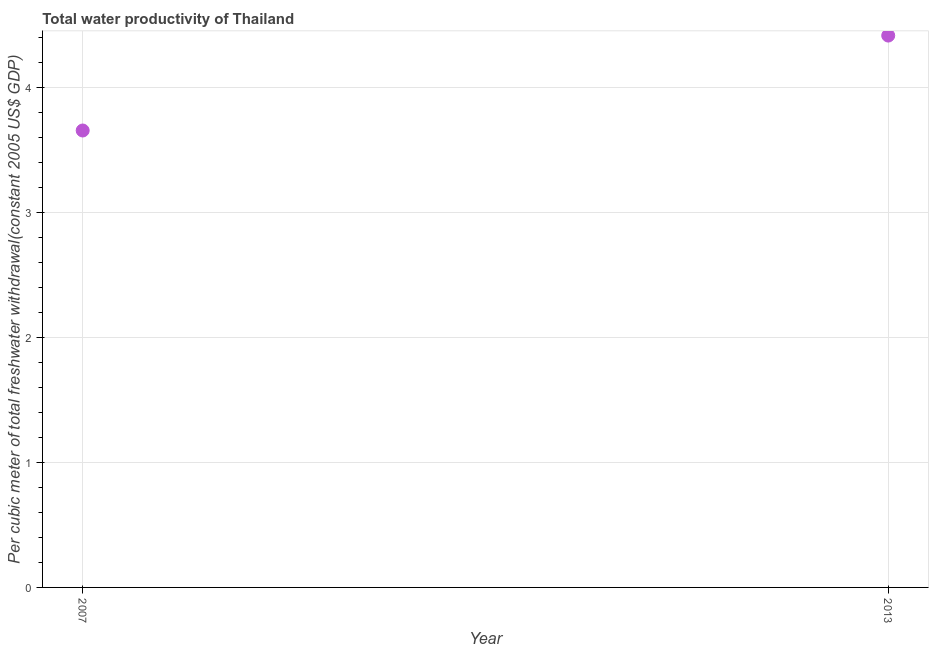What is the total water productivity in 2013?
Keep it short and to the point. 4.42. Across all years, what is the maximum total water productivity?
Provide a short and direct response. 4.42. Across all years, what is the minimum total water productivity?
Offer a terse response. 3.66. In which year was the total water productivity maximum?
Your answer should be compact. 2013. In which year was the total water productivity minimum?
Your answer should be compact. 2007. What is the sum of the total water productivity?
Provide a succinct answer. 8.07. What is the difference between the total water productivity in 2007 and 2013?
Provide a short and direct response. -0.76. What is the average total water productivity per year?
Provide a short and direct response. 4.04. What is the median total water productivity?
Your response must be concise. 4.04. In how many years, is the total water productivity greater than 3.4 US$?
Offer a terse response. 2. Do a majority of the years between 2013 and 2007 (inclusive) have total water productivity greater than 0.2 US$?
Your response must be concise. No. What is the ratio of the total water productivity in 2007 to that in 2013?
Your answer should be very brief. 0.83. How many years are there in the graph?
Keep it short and to the point. 2. Does the graph contain grids?
Provide a succinct answer. Yes. What is the title of the graph?
Make the answer very short. Total water productivity of Thailand. What is the label or title of the X-axis?
Offer a very short reply. Year. What is the label or title of the Y-axis?
Make the answer very short. Per cubic meter of total freshwater withdrawal(constant 2005 US$ GDP). What is the Per cubic meter of total freshwater withdrawal(constant 2005 US$ GDP) in 2007?
Make the answer very short. 3.66. What is the Per cubic meter of total freshwater withdrawal(constant 2005 US$ GDP) in 2013?
Offer a very short reply. 4.42. What is the difference between the Per cubic meter of total freshwater withdrawal(constant 2005 US$ GDP) in 2007 and 2013?
Your answer should be compact. -0.76. What is the ratio of the Per cubic meter of total freshwater withdrawal(constant 2005 US$ GDP) in 2007 to that in 2013?
Your response must be concise. 0.83. 